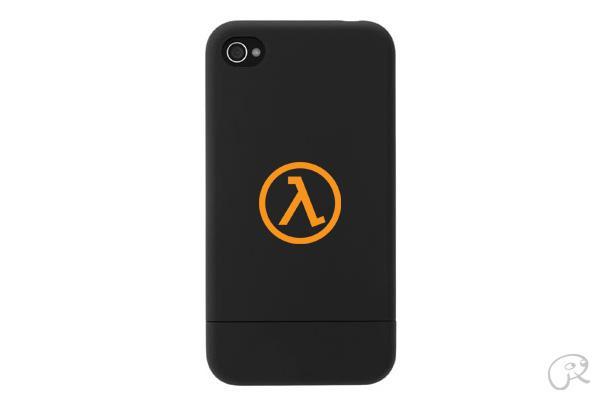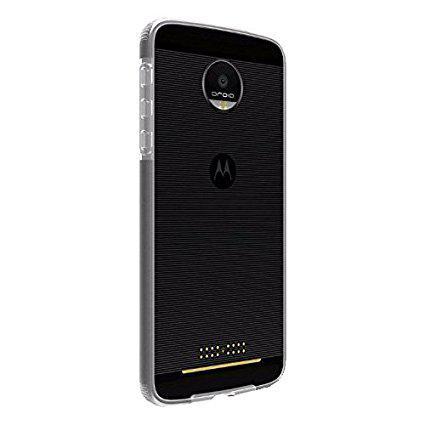The first image is the image on the left, the second image is the image on the right. For the images displayed, is the sentence "There is a colorful remote control with non-grid buttons in one image, and a black piece of electronics in the other." factually correct? Answer yes or no. No. The first image is the image on the left, the second image is the image on the right. Examine the images to the left and right. Is the description "There are two phones and one of them is ovalish." accurate? Answer yes or no. No. 